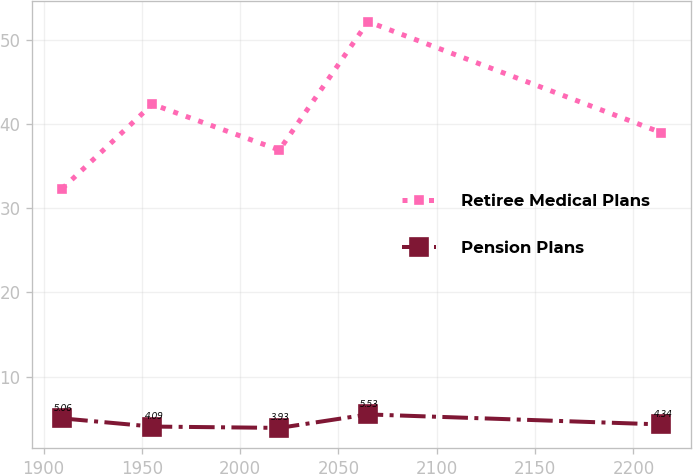Convert chart to OTSL. <chart><loc_0><loc_0><loc_500><loc_500><line_chart><ecel><fcel>Retiree Medical Plans<fcel>Pension Plans<nl><fcel>1909.51<fcel>32.32<fcel>5.06<nl><fcel>1955.34<fcel>42.33<fcel>4.09<nl><fcel>2019.93<fcel>36.9<fcel>3.93<nl><fcel>2065.02<fcel>52.13<fcel>5.53<nl><fcel>2214.16<fcel>38.96<fcel>4.34<nl></chart> 